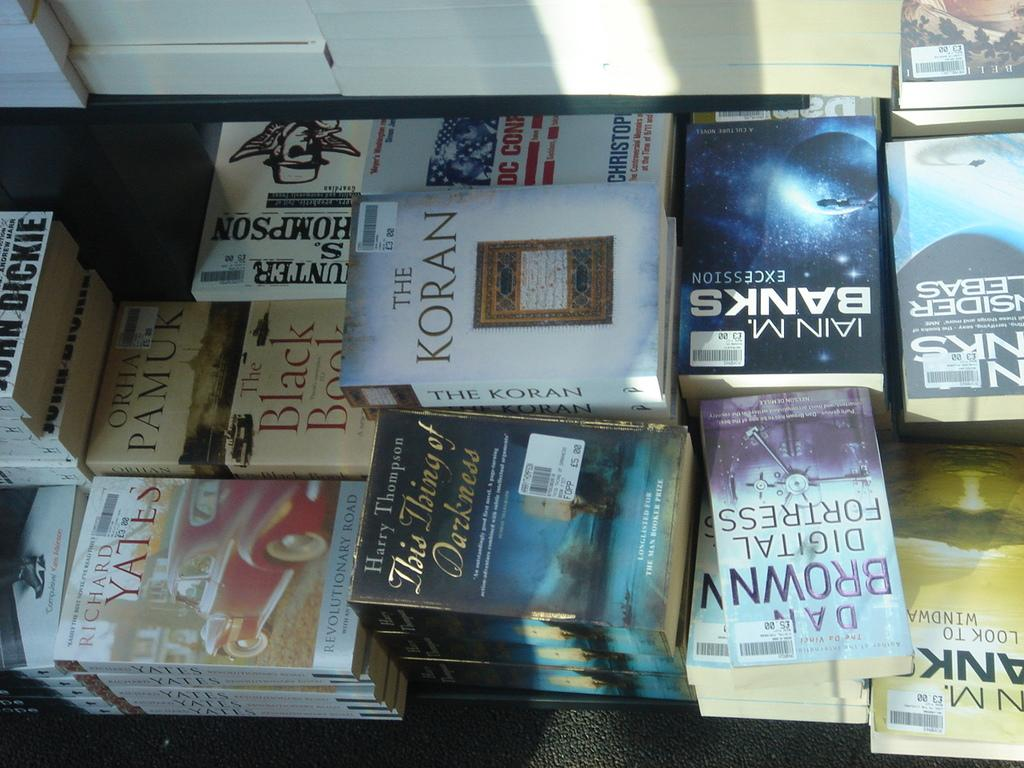<image>
Share a concise interpretation of the image provided. A stack of various books including The Koran. 